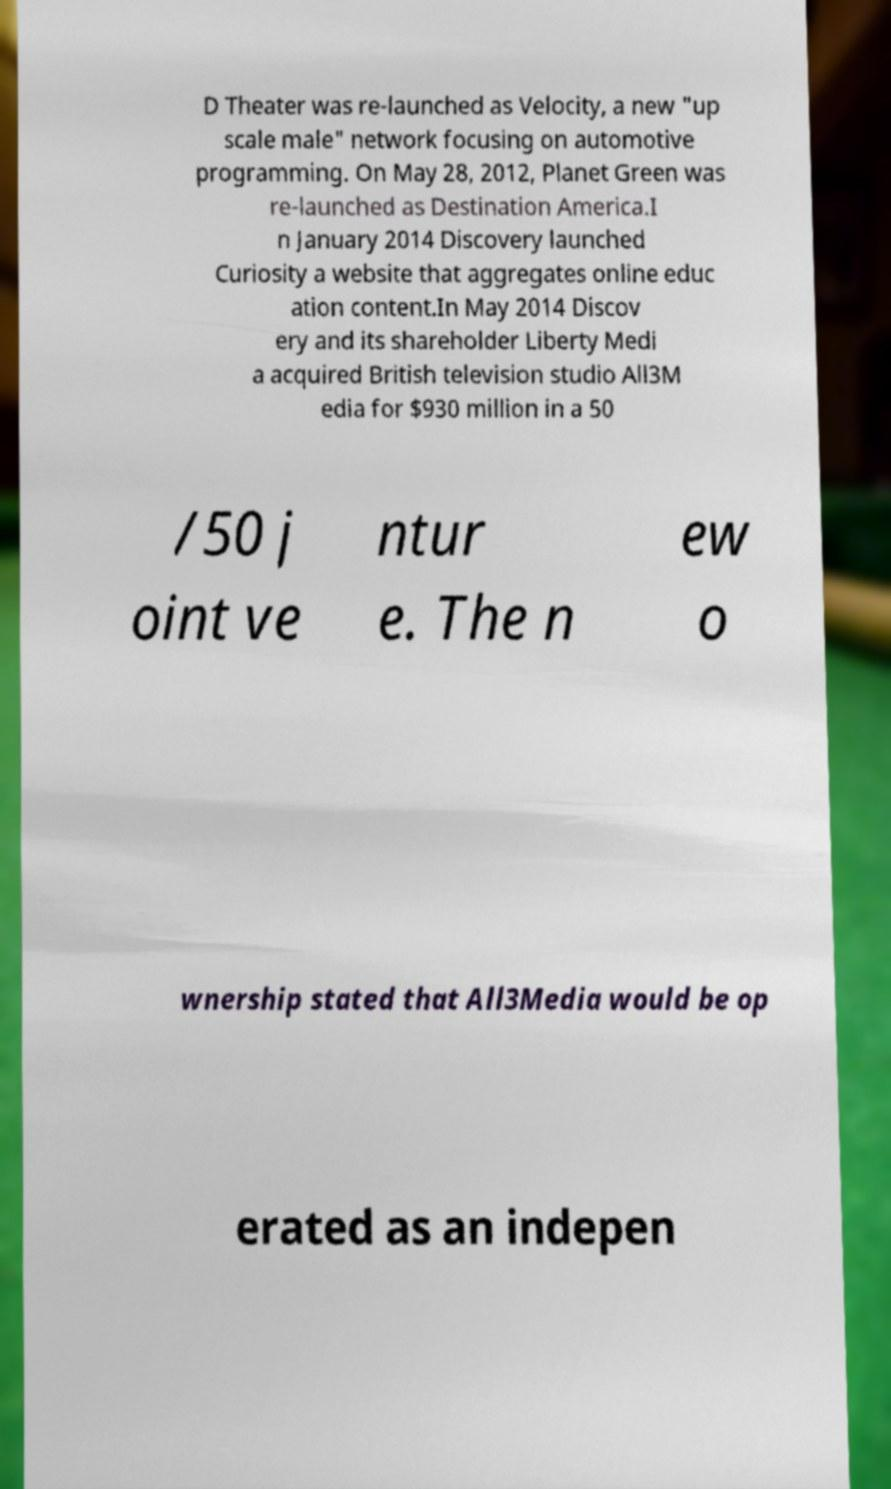Please read and relay the text visible in this image. What does it say? D Theater was re-launched as Velocity, a new "up scale male" network focusing on automotive programming. On May 28, 2012, Planet Green was re-launched as Destination America.I n January 2014 Discovery launched Curiosity a website that aggregates online educ ation content.In May 2014 Discov ery and its shareholder Liberty Medi a acquired British television studio All3M edia for $930 million in a 50 /50 j oint ve ntur e. The n ew o wnership stated that All3Media would be op erated as an indepen 